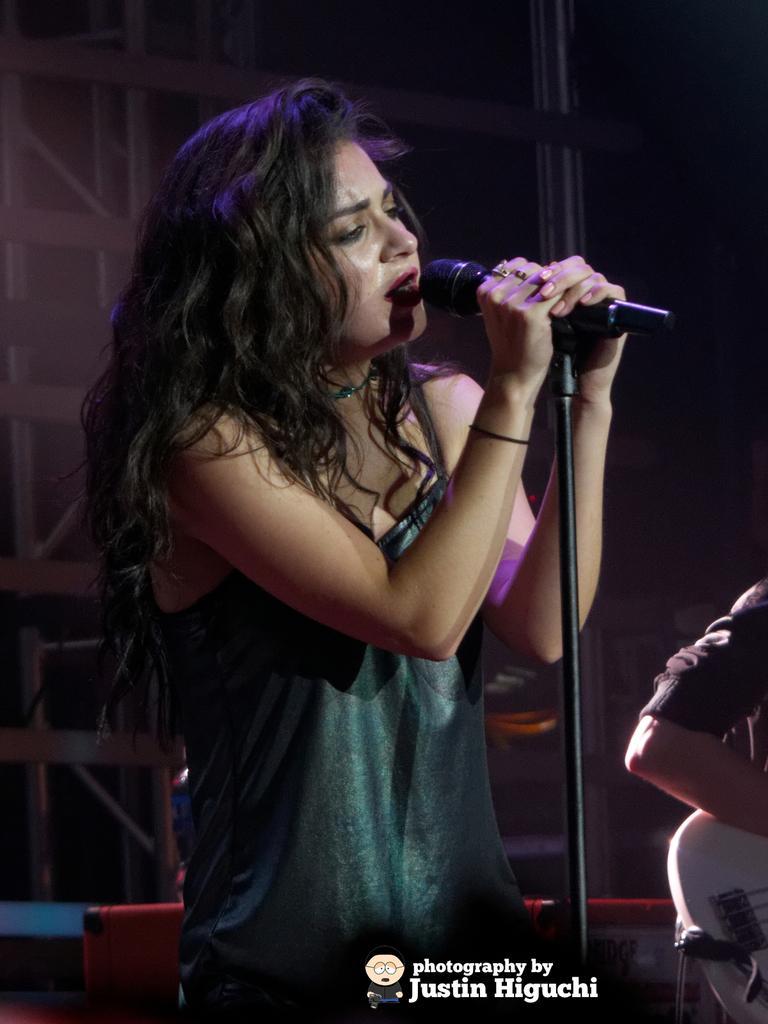Describe this image in one or two sentences. In this picture we can see a girl wearing a green top is singing on the microphone. Beside there a half image of the boy who is sitting and playing the white guitar. Behind there is a pipes frame and in the front we can see some quote on the bottom side of the image. 